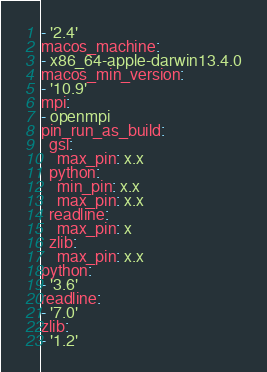Convert code to text. <code><loc_0><loc_0><loc_500><loc_500><_YAML_>- '2.4'
macos_machine:
- x86_64-apple-darwin13.4.0
macos_min_version:
- '10.9'
mpi:
- openmpi
pin_run_as_build:
  gsl:
    max_pin: x.x
  python:
    min_pin: x.x
    max_pin: x.x
  readline:
    max_pin: x
  zlib:
    max_pin: x.x
python:
- '3.6'
readline:
- '7.0'
zlib:
- '1.2'
</code> 